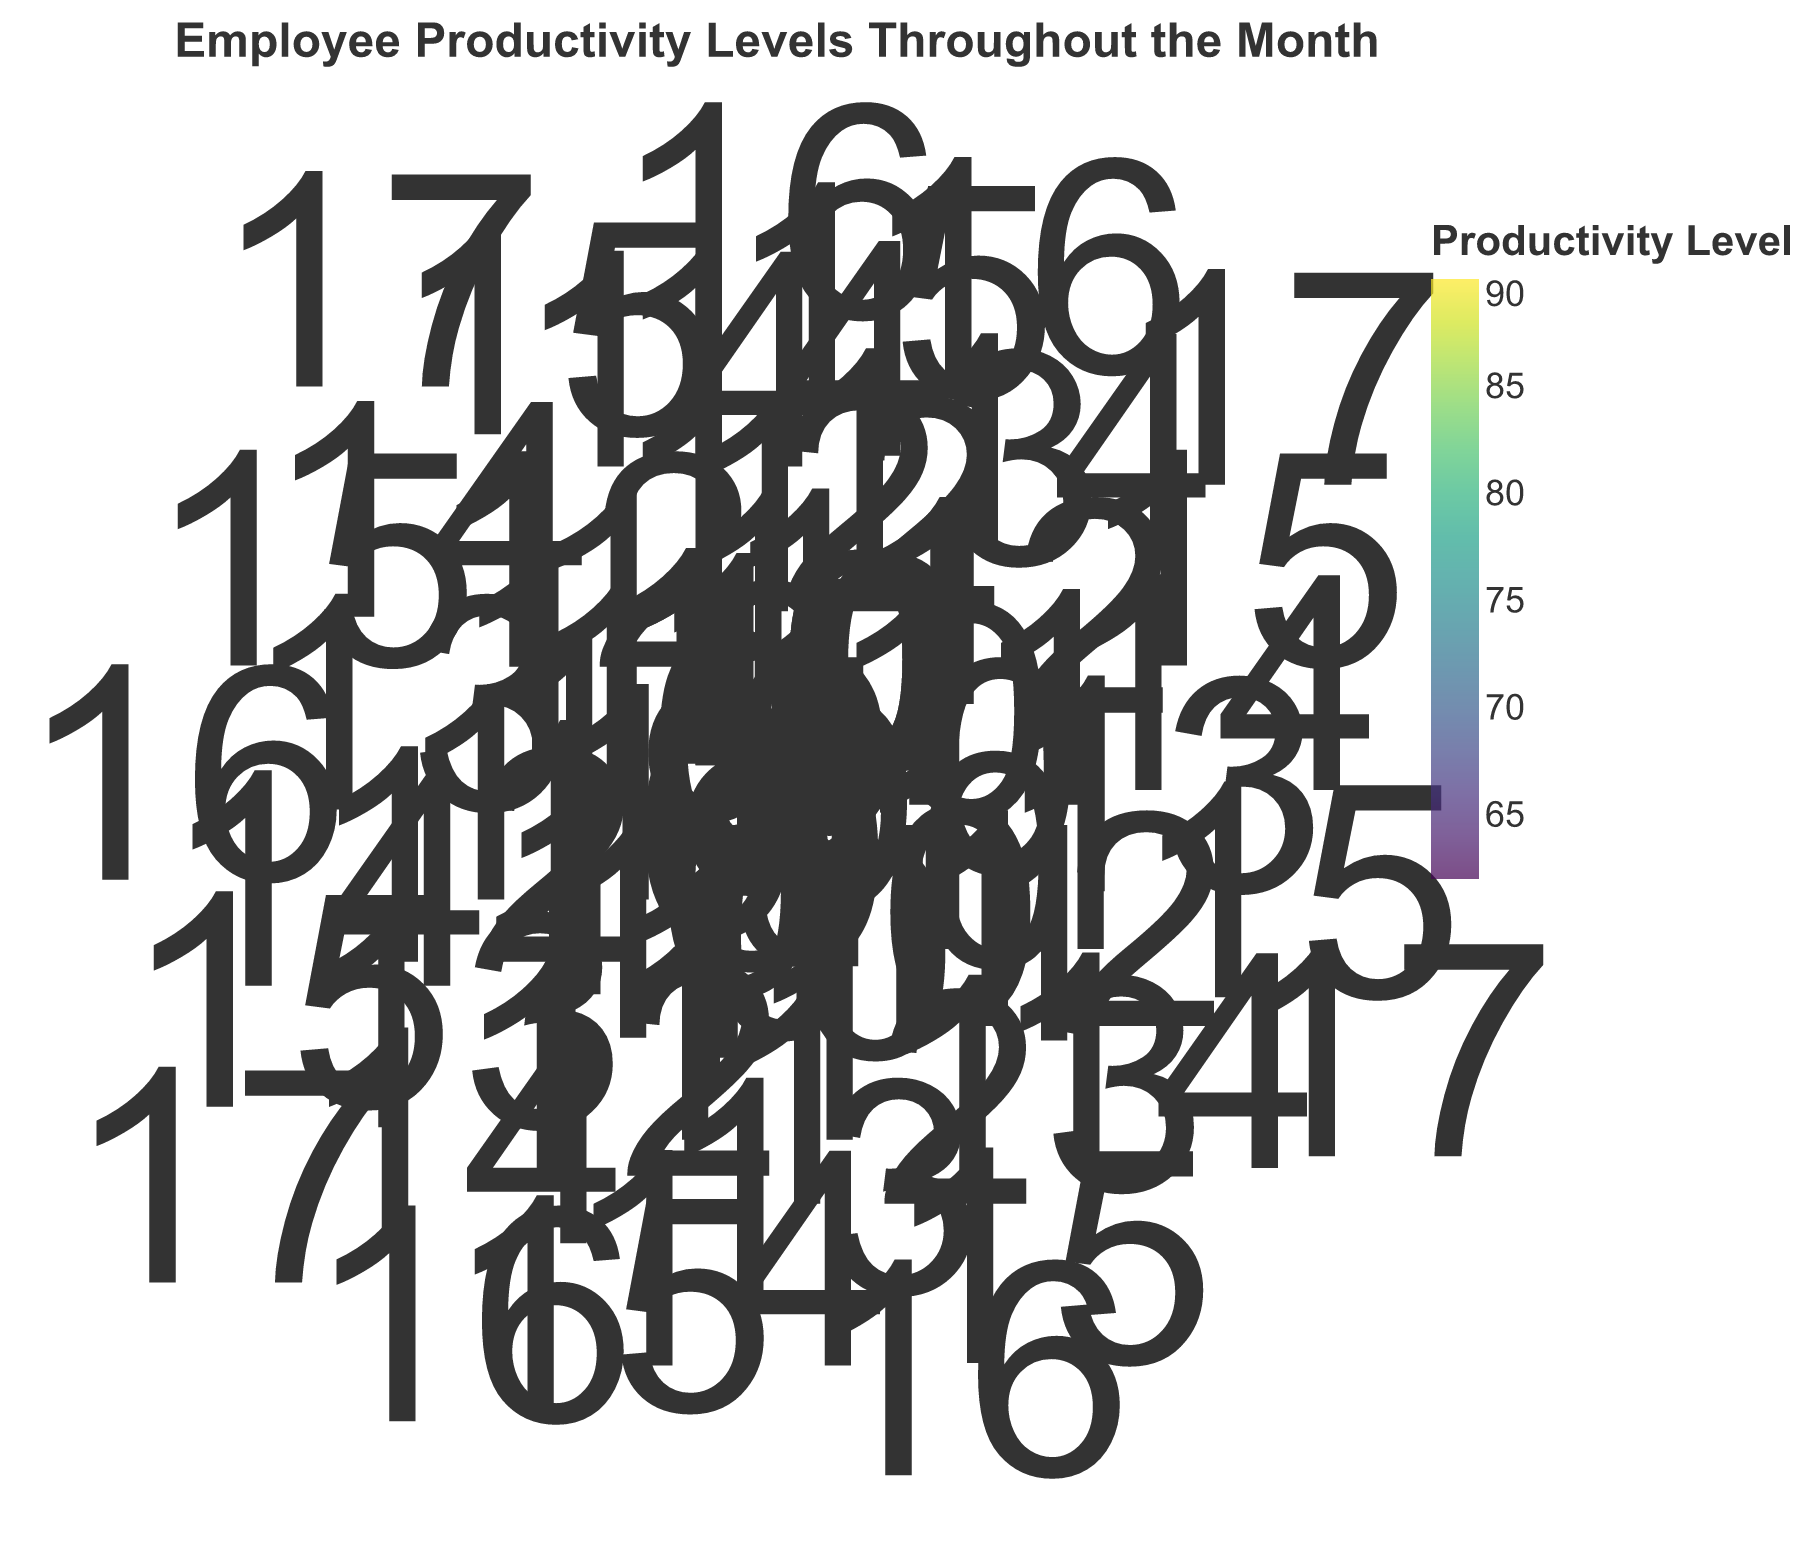What is the highest productivity level shown in the figure? Identify the data point with the highest color intensity corresponding to the highest productivity level.
Answer: 90 Which days have a productivity level of 90 at some point in time? Look for the data points where the color representing the productivity level is 90 and identify the days from the theta axis.
Answer: Day 17 During which times of the day do employees generally show higher productivity levels? Observe the radial distribution of the points with higher color intensity, which represents higher productivity levels. The times around 9 AM to 11 AM show higher productivity levels more frequently.
Answer: 9 AM to 11 AM How does the productivity level vary between 10 AM and 14 PM? Compare the color intensity of points corresponding to 10 AM and 14 PM. Generally, points at 10 AM show higher color intensity than those at 14 PM, indicating higher productivity levels in the morning.
Answer: Higher at 10 AM On which day and at what time was the lowest productivity level observed? Identify the least color-intense data point representing the lowest productivity level and read the corresponding day and time from the axes. The lowest productivity level observed is on Day 13 at 15 PM with a productivity level of 62.
Answer: Day 13, 15 PM What is the average productivity level around 12 PM across all days? Filter the points approximately at 12 PM and calculate their average based on the color intensity.
Answer: 73.6 How does the productivity level around 13 PM compare to the productivity level around 15 PM? Compare the color intensities of points at 13 PM and 15 PM across multiple days, 13 PM generally shows higher productivity levels compared to 15 PM.
Answer: Higher at 13 PM Are there any clear cyclic patterns visible for productivity levels throughout a day? Inspect for any recurring color patterns radiating from the center outward, noting any consistent levels and periods of high or low productivity. Notably, morning levels often start high and decrease toward the afternoon, suggesting a cyclic pattern in employee productivity.
Answer: Yes, cyclic pattern noticed How does productivity fluctuate throughout the month? Look at the circle's angular distribution and identify trends in color intensity from day 1 to day 30, noting any significant changes over this period. Generally, productivity is spiking early in the month and tapering off slightly towards the end.
Answer: Early spike, slight taper What is the productivity level trend at 10 AM throughout the month? Track all the data points at the radial distance corresponding to 10 AM around the entire circle and see if productivity colors lighten or darken consistently.
Answer: Slight decrease throughout the month 